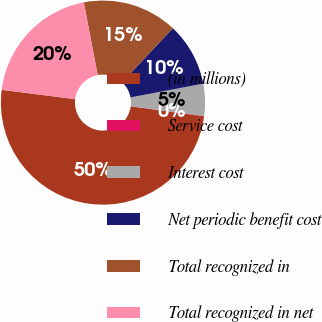<chart> <loc_0><loc_0><loc_500><loc_500><pie_chart><fcel>(in millions)<fcel>Service cost<fcel>Interest cost<fcel>Net periodic benefit cost<fcel>Total recognized in<fcel>Total recognized in net<nl><fcel>49.85%<fcel>0.07%<fcel>5.05%<fcel>10.03%<fcel>15.01%<fcel>19.99%<nl></chart> 